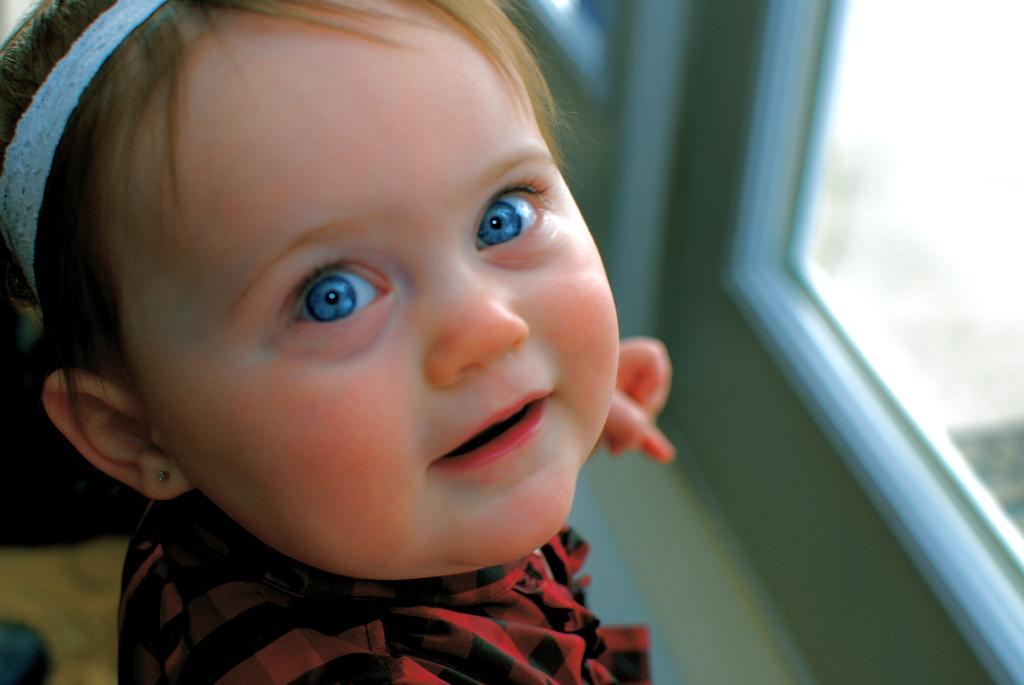Can you describe this image briefly? In this image, we can see a kid wearing a headband and smiling. Background we can see a blur view. Here there is a glass window, floor. 